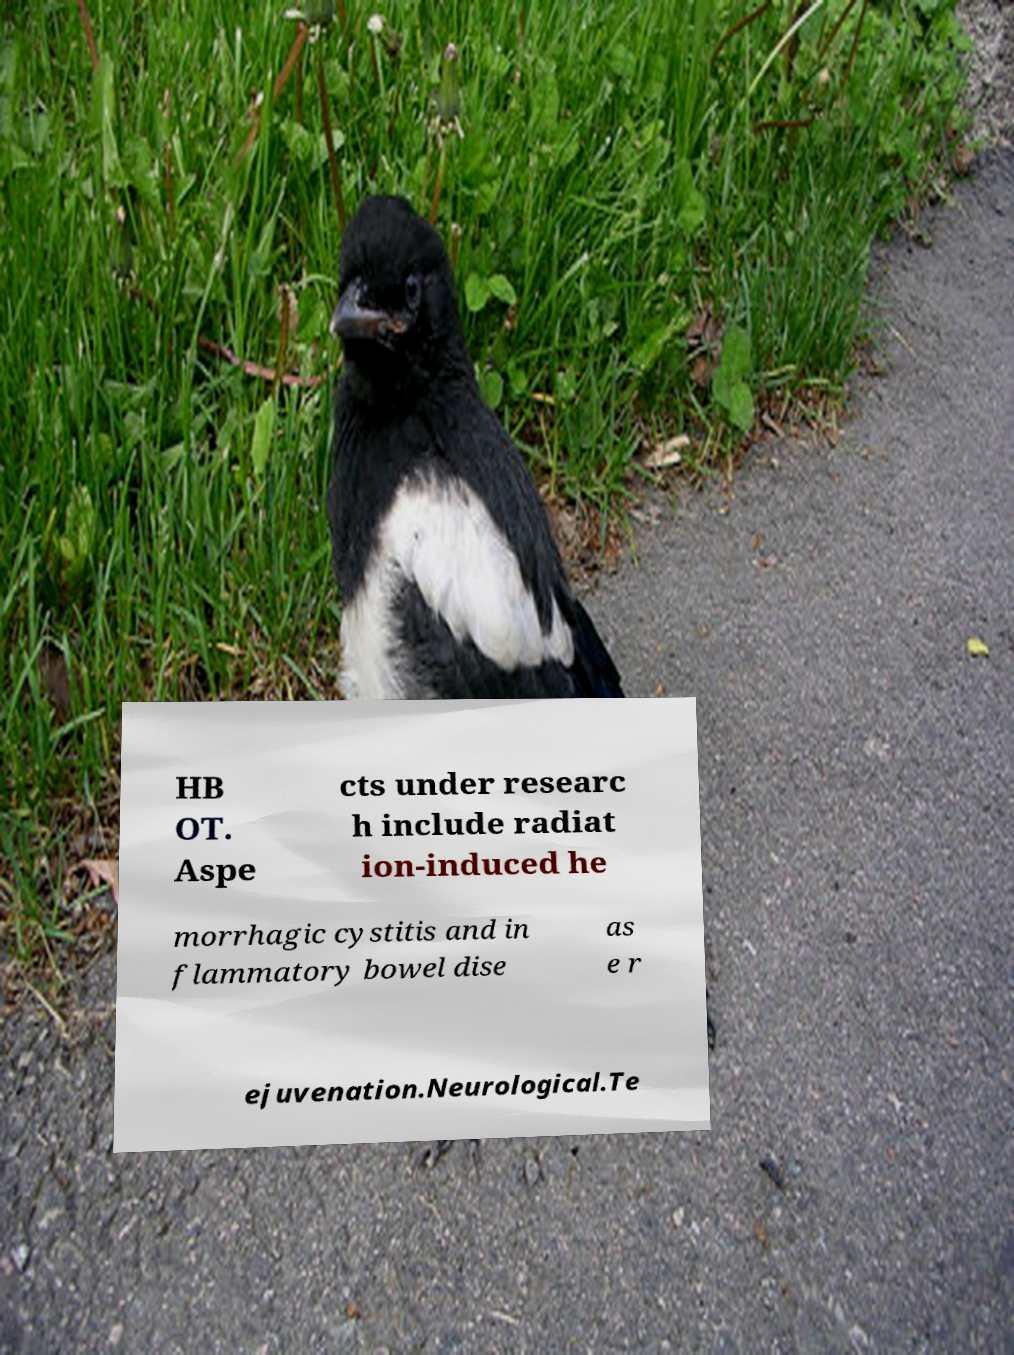Can you accurately transcribe the text from the provided image for me? HB OT. Aspe cts under researc h include radiat ion-induced he morrhagic cystitis and in flammatory bowel dise as e r ejuvenation.Neurological.Te 